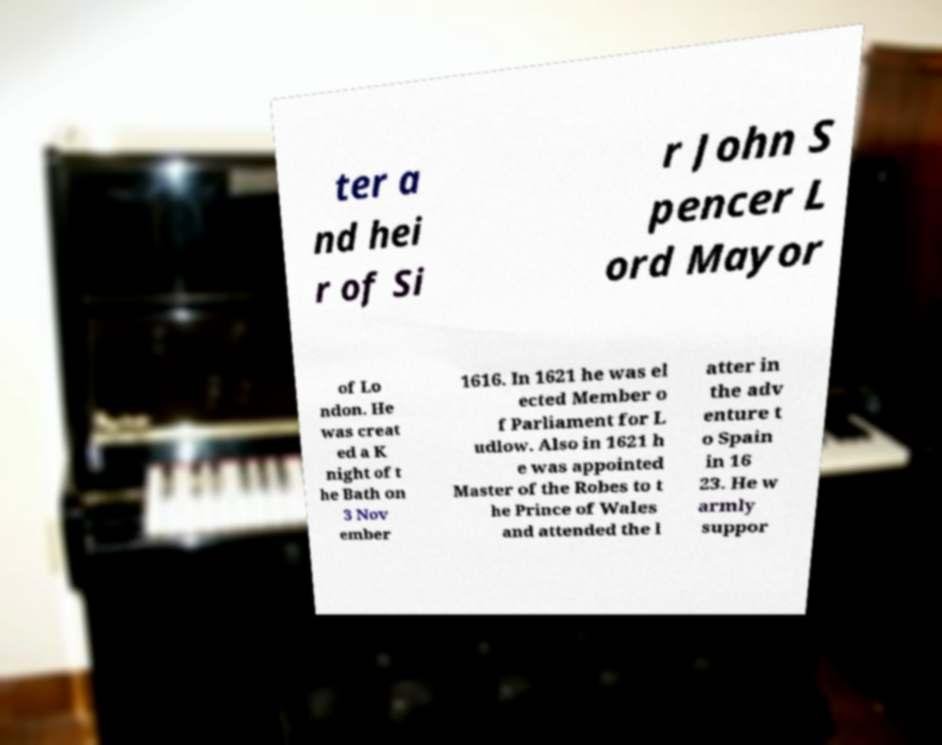I need the written content from this picture converted into text. Can you do that? ter a nd hei r of Si r John S pencer L ord Mayor of Lo ndon. He was creat ed a K night of t he Bath on 3 Nov ember 1616. In 1621 he was el ected Member o f Parliament for L udlow. Also in 1621 h e was appointed Master of the Robes to t he Prince of Wales and attended the l atter in the adv enture t o Spain in 16 23. He w armly suppor 